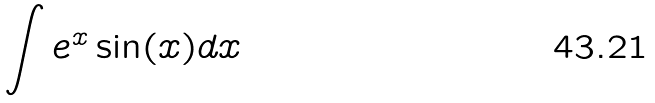<formula> <loc_0><loc_0><loc_500><loc_500>\int e ^ { x } \sin ( x ) d x</formula> 